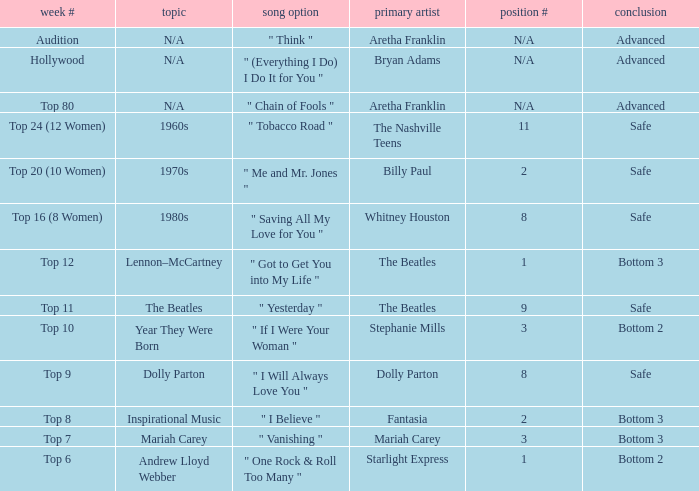Name the order number for the beatles and result is safe 9.0. 